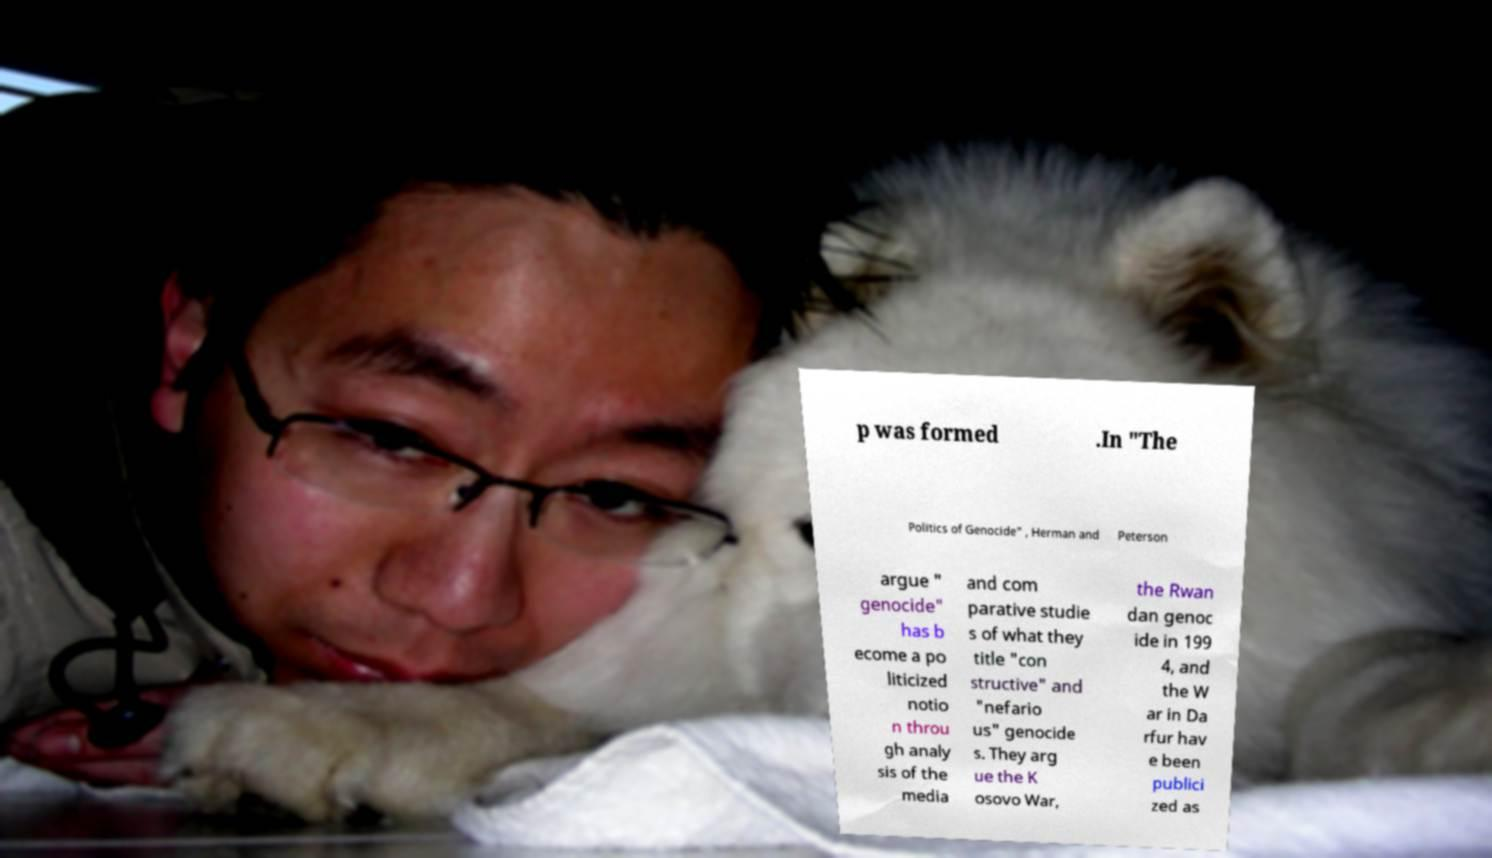Can you read and provide the text displayed in the image?This photo seems to have some interesting text. Can you extract and type it out for me? p was formed .In "The Politics of Genocide" , Herman and Peterson argue " genocide" has b ecome a po liticized notio n throu gh analy sis of the media and com parative studie s of what they title "con structive" and "nefario us" genocide s. They arg ue the K osovo War, the Rwan dan genoc ide in 199 4, and the W ar in Da rfur hav e been publici zed as 